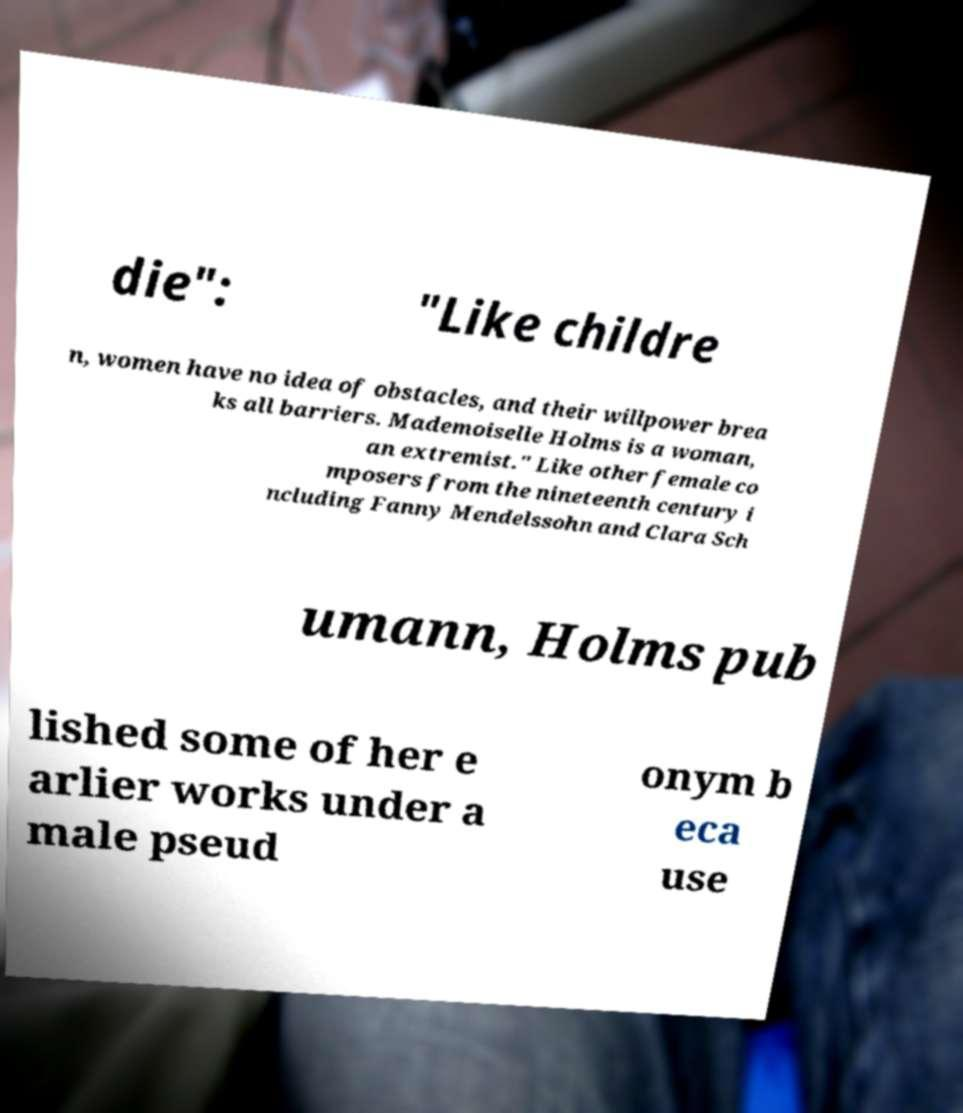Can you read and provide the text displayed in the image?This photo seems to have some interesting text. Can you extract and type it out for me? die": "Like childre n, women have no idea of obstacles, and their willpower brea ks all barriers. Mademoiselle Holms is a woman, an extremist." Like other female co mposers from the nineteenth century i ncluding Fanny Mendelssohn and Clara Sch umann, Holms pub lished some of her e arlier works under a male pseud onym b eca use 